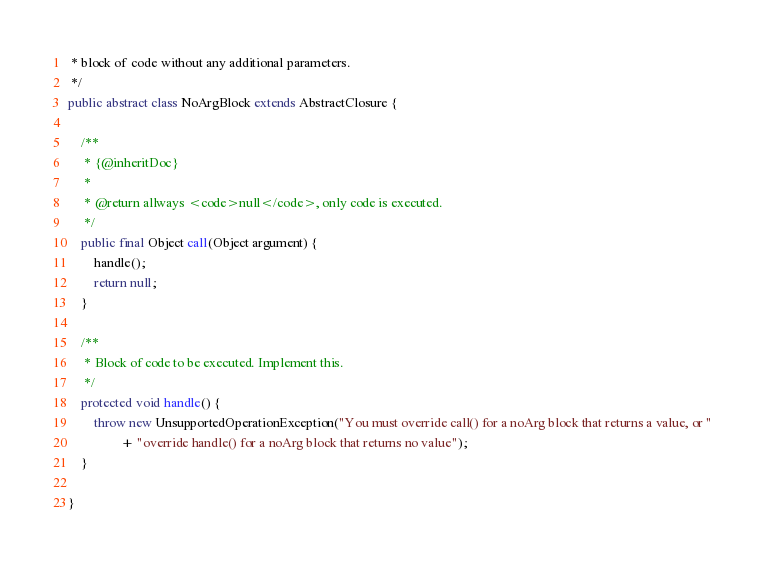Convert code to text. <code><loc_0><loc_0><loc_500><loc_500><_Java_> * block of code without any additional parameters.
 */
public abstract class NoArgBlock extends AbstractClosure {

	/**
	 * {@inheritDoc}
	 *
	 * @return allways <code>null</code>, only code is executed.
	 */
	public final Object call(Object argument) {
		handle();
		return null;
	}

	/**
	 * Block of code to be executed. Implement this.
	 */
	protected void handle() {
		throw new UnsupportedOperationException("You must override call() for a noArg block that returns a value, or "
				+ "override handle() for a noArg block that returns no value");
	}

}
</code> 